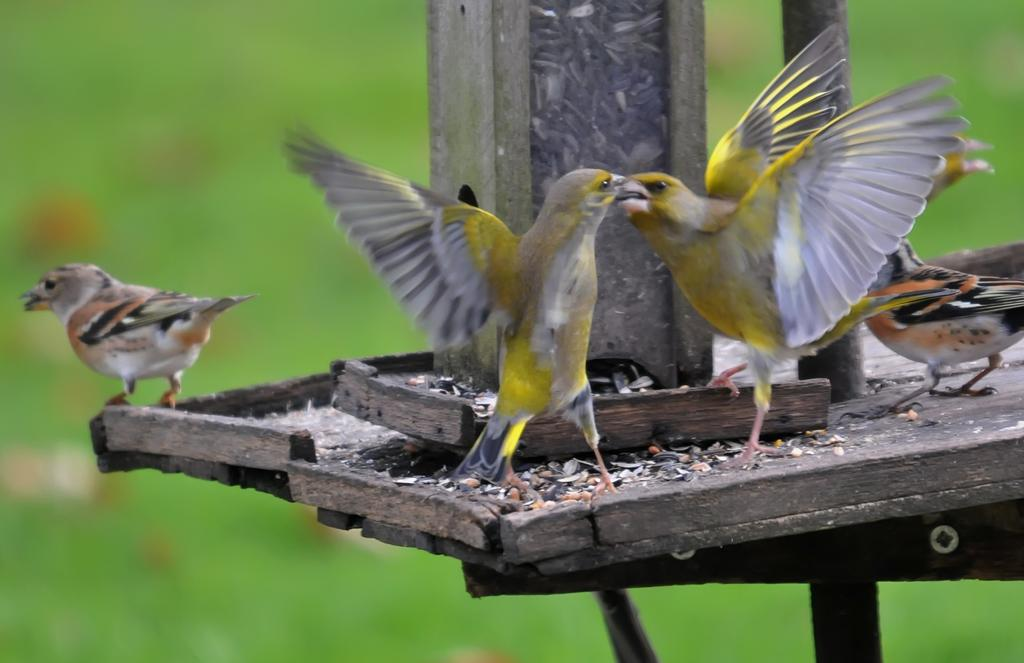What type of animals can be seen in the image? There are birds in the image. Where are the birds located? The birds are on a wooden stand. Can you describe the background of the image? The background of the image is blurred. How does the snow affect the birds in the image? There is no snow present in the image, so it does not affect the birds. What type of shame is the bird experiencing in the image? There is no indication of shame in the image; the birds are simply perched on a wooden stand. 